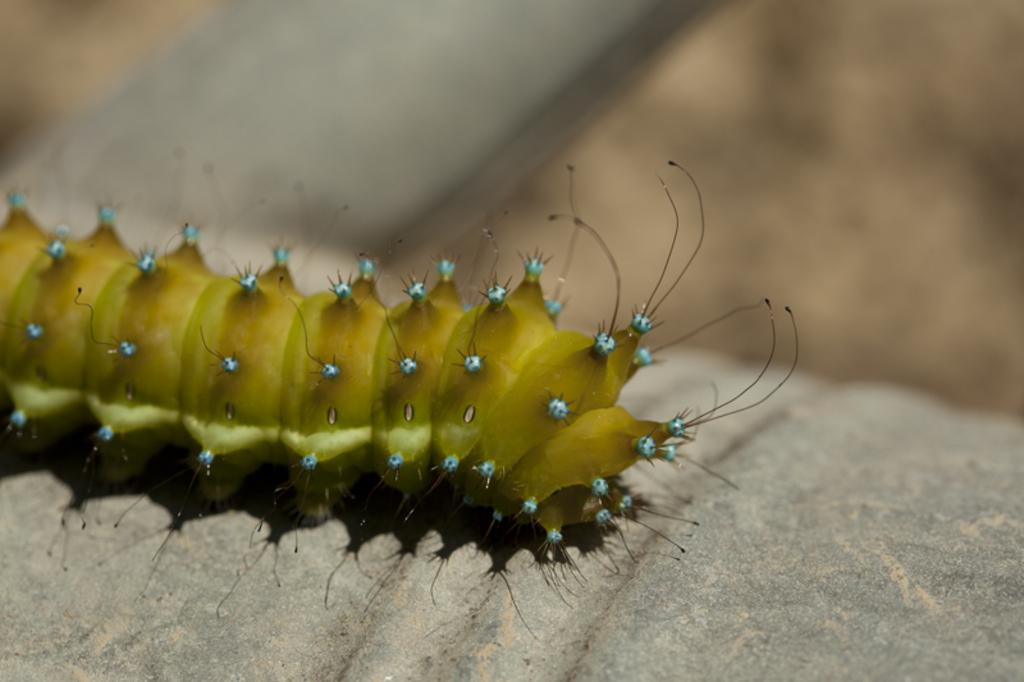What is the main subject of the image? There is a caterpillar in the image. Can you describe the caterpillar's location? The caterpillar is on a solid surface. What can be observed about the background of the image? The background of the image is blurred. What type of grass is growing around the tank in the image? There is no tank or grass present in the image; it features a caterpillar on a solid surface with a blurred background. How many chickens are visible in the image? There are no chickens present in the image. 